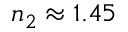<formula> <loc_0><loc_0><loc_500><loc_500>n _ { 2 } \approx 1 . 4 5</formula> 